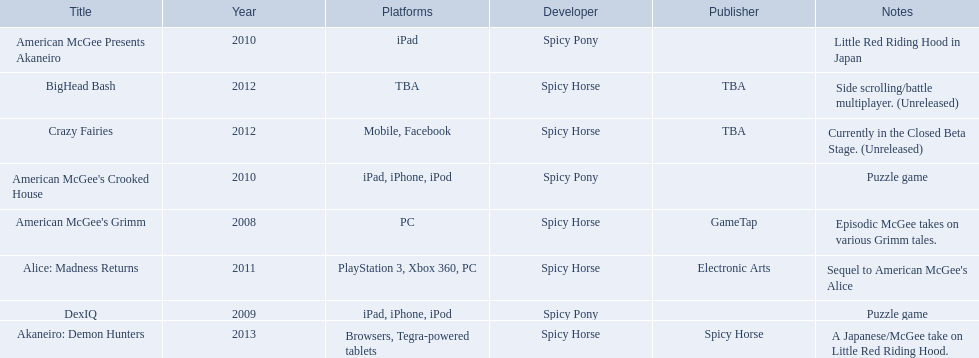What are all the titles? American McGee's Grimm, DexIQ, American McGee Presents Akaneiro, American McGee's Crooked House, Alice: Madness Returns, BigHead Bash, Crazy Fairies, Akaneiro: Demon Hunters. What platforms were they available on? PC, iPad, iPhone, iPod, iPad, iPad, iPhone, iPod, PlayStation 3, Xbox 360, PC, TBA, Mobile, Facebook, Browsers, Tegra-powered tablets. And which were available only on the ipad? American McGee Presents Akaneiro. I'm looking to parse the entire table for insights. Could you assist me with that? {'header': ['Title', 'Year', 'Platforms', 'Developer', 'Publisher', 'Notes'], 'rows': [['American McGee Presents Akaneiro', '2010', 'iPad', 'Spicy Pony', '', 'Little Red Riding Hood in Japan'], ['BigHead Bash', '2012', 'TBA', 'Spicy Horse', 'TBA', 'Side scrolling/battle multiplayer. (Unreleased)'], ['Crazy Fairies', '2012', 'Mobile, Facebook', 'Spicy Horse', 'TBA', 'Currently in the Closed Beta Stage. (Unreleased)'], ["American McGee's Crooked House", '2010', 'iPad, iPhone, iPod', 'Spicy Pony', '', 'Puzzle game'], ["American McGee's Grimm", '2008', 'PC', 'Spicy Horse', 'GameTap', 'Episodic McGee takes on various Grimm tales.'], ['Alice: Madness Returns', '2011', 'PlayStation 3, Xbox 360, PC', 'Spicy Horse', 'Electronic Arts', "Sequel to American McGee's Alice"], ['DexIQ', '2009', 'iPad, iPhone, iPod', 'Spicy Pony', '', 'Puzzle game'], ['Akaneiro: Demon Hunters', '2013', 'Browsers, Tegra-powered tablets', 'Spicy Horse', 'Spicy Horse', 'A Japanese/McGee take on Little Red Riding Hood.']]} 